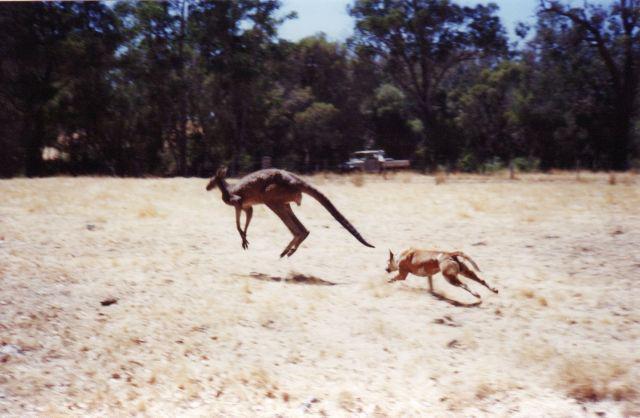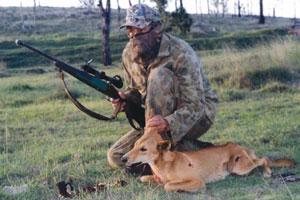The first image is the image on the left, the second image is the image on the right. For the images displayed, is the sentence "There is at least two canines in the right image." factually correct? Answer yes or no. No. The first image is the image on the left, the second image is the image on the right. Examine the images to the left and right. Is the description "In at least one image there is a single male in camo clothes holding a hunting gun near the dead brown fox." accurate? Answer yes or no. Yes. 